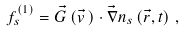Convert formula to latex. <formula><loc_0><loc_0><loc_500><loc_500>f _ { s } ^ { ( 1 ) } = \vec { G } \left ( \vec { v } \, \right ) \cdot \vec { \nabla } n _ { s } \left ( \vec { r } , t \right ) \, ,</formula> 